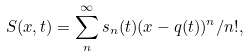<formula> <loc_0><loc_0><loc_500><loc_500>S ( x , t ) = \sum _ { n } ^ { \infty } s _ { n } ( t ) ( x - q ( t ) ) ^ { n } / n ! ,</formula> 